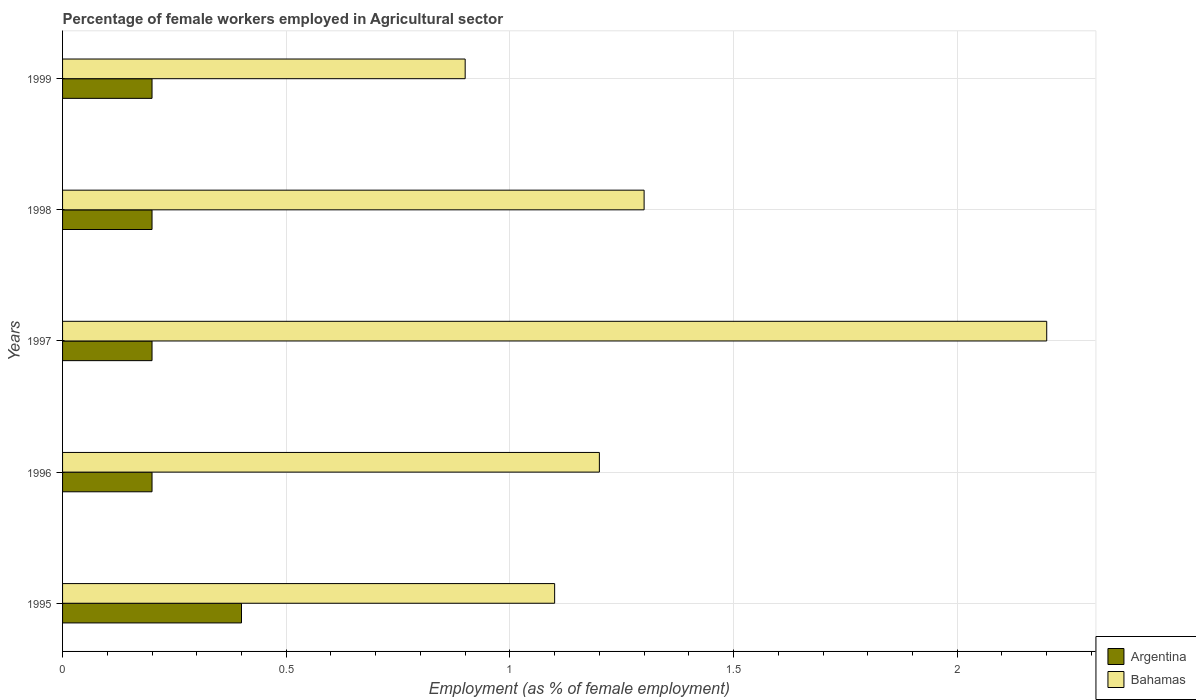What is the label of the 1st group of bars from the top?
Your answer should be very brief. 1999. What is the percentage of females employed in Agricultural sector in Bahamas in 1995?
Give a very brief answer. 1.1. Across all years, what is the maximum percentage of females employed in Agricultural sector in Bahamas?
Offer a very short reply. 2.2. Across all years, what is the minimum percentage of females employed in Agricultural sector in Argentina?
Provide a succinct answer. 0.2. In which year was the percentage of females employed in Agricultural sector in Bahamas maximum?
Make the answer very short. 1997. What is the total percentage of females employed in Agricultural sector in Bahamas in the graph?
Offer a very short reply. 6.7. What is the difference between the percentage of females employed in Agricultural sector in Bahamas in 1997 and that in 1999?
Make the answer very short. 1.3. What is the difference between the percentage of females employed in Agricultural sector in Bahamas in 1996 and the percentage of females employed in Agricultural sector in Argentina in 1999?
Provide a succinct answer. 1. What is the average percentage of females employed in Agricultural sector in Argentina per year?
Give a very brief answer. 0.24. In the year 1995, what is the difference between the percentage of females employed in Agricultural sector in Argentina and percentage of females employed in Agricultural sector in Bahamas?
Offer a very short reply. -0.7. In how many years, is the percentage of females employed in Agricultural sector in Bahamas greater than 1.8 %?
Keep it short and to the point. 1. Is the difference between the percentage of females employed in Agricultural sector in Argentina in 1996 and 1997 greater than the difference between the percentage of females employed in Agricultural sector in Bahamas in 1996 and 1997?
Give a very brief answer. Yes. What is the difference between the highest and the second highest percentage of females employed in Agricultural sector in Argentina?
Your response must be concise. 0.2. What is the difference between the highest and the lowest percentage of females employed in Agricultural sector in Argentina?
Your answer should be very brief. 0.2. In how many years, is the percentage of females employed in Agricultural sector in Bahamas greater than the average percentage of females employed in Agricultural sector in Bahamas taken over all years?
Your answer should be very brief. 1. Is the sum of the percentage of females employed in Agricultural sector in Bahamas in 1996 and 1999 greater than the maximum percentage of females employed in Agricultural sector in Argentina across all years?
Keep it short and to the point. Yes. What does the 2nd bar from the bottom in 1996 represents?
Provide a short and direct response. Bahamas. Are all the bars in the graph horizontal?
Offer a very short reply. Yes. Are the values on the major ticks of X-axis written in scientific E-notation?
Keep it short and to the point. No. Does the graph contain grids?
Your response must be concise. Yes. Where does the legend appear in the graph?
Your response must be concise. Bottom right. How are the legend labels stacked?
Offer a very short reply. Vertical. What is the title of the graph?
Provide a short and direct response. Percentage of female workers employed in Agricultural sector. What is the label or title of the X-axis?
Offer a terse response. Employment (as % of female employment). What is the Employment (as % of female employment) of Argentina in 1995?
Provide a short and direct response. 0.4. What is the Employment (as % of female employment) in Bahamas in 1995?
Offer a very short reply. 1.1. What is the Employment (as % of female employment) in Argentina in 1996?
Ensure brevity in your answer.  0.2. What is the Employment (as % of female employment) of Bahamas in 1996?
Your answer should be compact. 1.2. What is the Employment (as % of female employment) of Argentina in 1997?
Offer a very short reply. 0.2. What is the Employment (as % of female employment) in Bahamas in 1997?
Give a very brief answer. 2.2. What is the Employment (as % of female employment) of Argentina in 1998?
Provide a succinct answer. 0.2. What is the Employment (as % of female employment) in Bahamas in 1998?
Ensure brevity in your answer.  1.3. What is the Employment (as % of female employment) of Argentina in 1999?
Ensure brevity in your answer.  0.2. What is the Employment (as % of female employment) in Bahamas in 1999?
Give a very brief answer. 0.9. Across all years, what is the maximum Employment (as % of female employment) in Argentina?
Your answer should be compact. 0.4. Across all years, what is the maximum Employment (as % of female employment) in Bahamas?
Provide a short and direct response. 2.2. Across all years, what is the minimum Employment (as % of female employment) of Argentina?
Ensure brevity in your answer.  0.2. Across all years, what is the minimum Employment (as % of female employment) in Bahamas?
Ensure brevity in your answer.  0.9. What is the difference between the Employment (as % of female employment) of Argentina in 1995 and that in 1997?
Offer a very short reply. 0.2. What is the difference between the Employment (as % of female employment) in Bahamas in 1995 and that in 1997?
Make the answer very short. -1.1. What is the difference between the Employment (as % of female employment) in Bahamas in 1995 and that in 1999?
Provide a short and direct response. 0.2. What is the difference between the Employment (as % of female employment) of Argentina in 1996 and that in 1997?
Make the answer very short. 0. What is the difference between the Employment (as % of female employment) of Argentina in 1996 and that in 1998?
Provide a short and direct response. 0. What is the difference between the Employment (as % of female employment) of Bahamas in 1996 and that in 1998?
Provide a succinct answer. -0.1. What is the difference between the Employment (as % of female employment) of Bahamas in 1997 and that in 1999?
Your answer should be very brief. 1.3. What is the difference between the Employment (as % of female employment) of Argentina in 1995 and the Employment (as % of female employment) of Bahamas in 1997?
Your answer should be very brief. -1.8. What is the difference between the Employment (as % of female employment) of Argentina in 1995 and the Employment (as % of female employment) of Bahamas in 1998?
Ensure brevity in your answer.  -0.9. What is the difference between the Employment (as % of female employment) of Argentina in 1995 and the Employment (as % of female employment) of Bahamas in 1999?
Your answer should be very brief. -0.5. What is the difference between the Employment (as % of female employment) of Argentina in 1996 and the Employment (as % of female employment) of Bahamas in 1997?
Your answer should be compact. -2. What is the difference between the Employment (as % of female employment) of Argentina in 1996 and the Employment (as % of female employment) of Bahamas in 1999?
Ensure brevity in your answer.  -0.7. What is the difference between the Employment (as % of female employment) in Argentina in 1997 and the Employment (as % of female employment) in Bahamas in 1998?
Provide a succinct answer. -1.1. What is the difference between the Employment (as % of female employment) in Argentina in 1997 and the Employment (as % of female employment) in Bahamas in 1999?
Provide a succinct answer. -0.7. What is the difference between the Employment (as % of female employment) of Argentina in 1998 and the Employment (as % of female employment) of Bahamas in 1999?
Ensure brevity in your answer.  -0.7. What is the average Employment (as % of female employment) in Argentina per year?
Your response must be concise. 0.24. What is the average Employment (as % of female employment) of Bahamas per year?
Offer a very short reply. 1.34. In the year 1999, what is the difference between the Employment (as % of female employment) of Argentina and Employment (as % of female employment) of Bahamas?
Make the answer very short. -0.7. What is the ratio of the Employment (as % of female employment) of Argentina in 1995 to that in 1996?
Your answer should be compact. 2. What is the ratio of the Employment (as % of female employment) of Bahamas in 1995 to that in 1996?
Provide a short and direct response. 0.92. What is the ratio of the Employment (as % of female employment) in Argentina in 1995 to that in 1997?
Your answer should be very brief. 2. What is the ratio of the Employment (as % of female employment) of Bahamas in 1995 to that in 1997?
Offer a terse response. 0.5. What is the ratio of the Employment (as % of female employment) of Bahamas in 1995 to that in 1998?
Give a very brief answer. 0.85. What is the ratio of the Employment (as % of female employment) in Bahamas in 1995 to that in 1999?
Offer a terse response. 1.22. What is the ratio of the Employment (as % of female employment) in Bahamas in 1996 to that in 1997?
Provide a short and direct response. 0.55. What is the ratio of the Employment (as % of female employment) in Bahamas in 1996 to that in 1998?
Offer a very short reply. 0.92. What is the ratio of the Employment (as % of female employment) of Argentina in 1996 to that in 1999?
Your answer should be compact. 1. What is the ratio of the Employment (as % of female employment) in Bahamas in 1996 to that in 1999?
Offer a very short reply. 1.33. What is the ratio of the Employment (as % of female employment) in Bahamas in 1997 to that in 1998?
Keep it short and to the point. 1.69. What is the ratio of the Employment (as % of female employment) of Bahamas in 1997 to that in 1999?
Make the answer very short. 2.44. What is the ratio of the Employment (as % of female employment) in Argentina in 1998 to that in 1999?
Give a very brief answer. 1. What is the ratio of the Employment (as % of female employment) in Bahamas in 1998 to that in 1999?
Make the answer very short. 1.44. What is the difference between the highest and the second highest Employment (as % of female employment) of Argentina?
Make the answer very short. 0.2. What is the difference between the highest and the lowest Employment (as % of female employment) in Bahamas?
Offer a terse response. 1.3. 